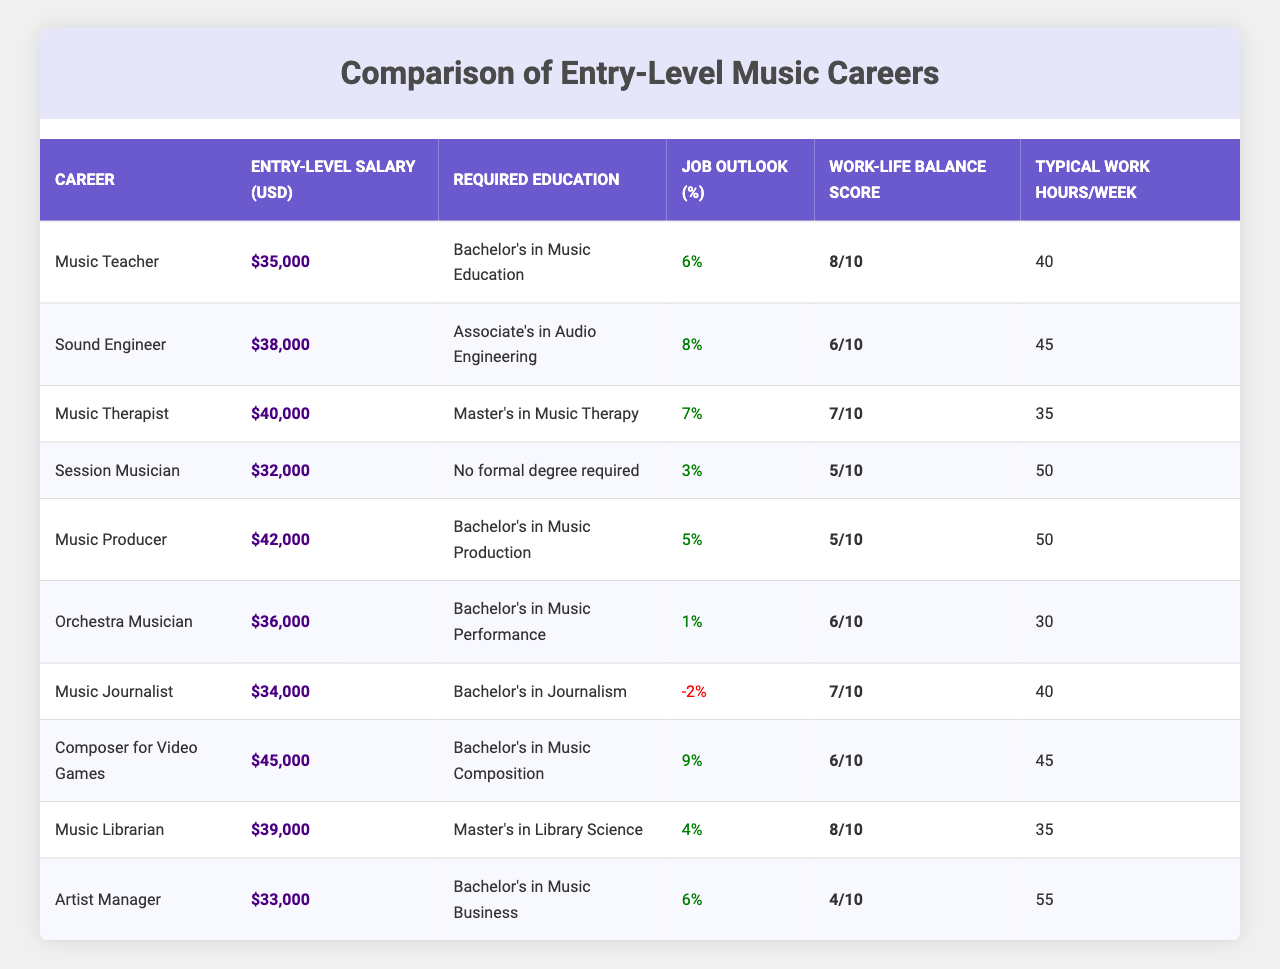What is the entry-level salary for a Music Teacher? The table lists the entry-level salary for a Music Teacher as $35,000.
Answer: $35,000 Which career has the highest entry-level salary? Looking through the entry-level salary column, the career with the highest salary is Composer for Video Games, with a salary of $45,000.
Answer: Composer for Video Games How many careers require a Bachelor's degree? By reviewing the required education column, I count 7 careers that list a Bachelor's degree as their requirement.
Answer: 7 What is the average entry-level salary for all careers listed? To find the average, I sum all the entry-level salaries (35,000 + 38,000 + 40,000 + 32,000 + 42,000 + 36,000 + 34,000 + 45,000 + 39,000 + 33,000 =  392,000) and divide by the number of careers (10), which gives me 392,000 / 10 = 39,200.
Answer: $39,200 Is the job outlook for a Sound Engineer positive? The job outlook percentage for a Sound Engineer is 8%, which is greater than 0, indicating a positive job outlook.
Answer: Yes Which career has the best work-life balance score? Upon examining the work-life balance score column, Music Teacher and Music Librarian both have the highest score of 8.
Answer: Music Teacher and Music Librarian What is the difference in entry-level salaries between a Music Producer and an Orchestra Musician? The entry-level salary for a Music Producer is $42,000 and for an Orchestra Musician is $36,000. The difference is $42,000 - $36,000 = $6,000.
Answer: $6,000 Which career has the lowest typical work hours per week? Checking the typical work hours per week, I see that an Orchestra Musician has the lowest with 30 hours.
Answer: Orchestra Musician How many careers have a job outlook under 5%? I count the careers with a job outlook less than 5%, which are Music Journalist (-2%) and Orchestra Musician (1%). That totals to 2 careers.
Answer: 2 What is the total work-life balance score of all careers combined? I sum the work-life balance scores (8 + 6 + 7 + 5 + 5 + 6 + 7 + 6 + 8 + 4 = 57) to get the total score.
Answer: 57 Which career types require a Master’s degree, and do any of them have a negative job outlook? The careers requiring a Master’s degree are Music Therapist and Music Librarian. The job outlook for Music Therapist is 7% (positive), while Music Librarian is 4% (also positive). Therefore, none have a negative job outlook.
Answer: No 